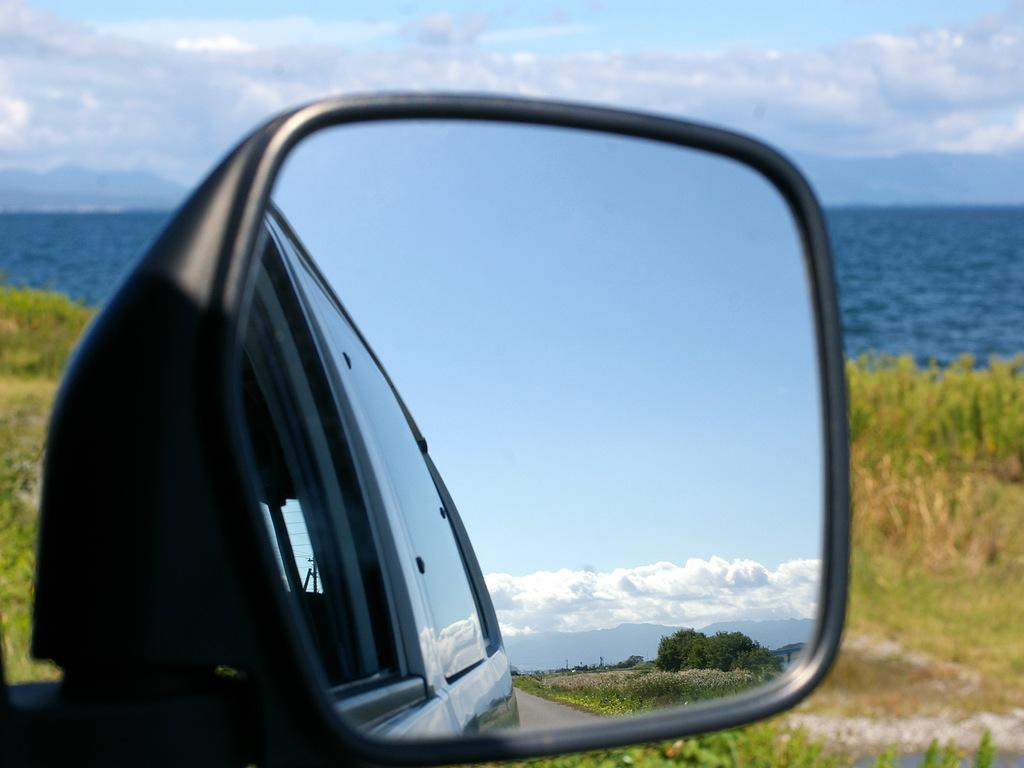What object in the image reflects its surroundings? The mirror in the image reflects its surroundings. What type of natural environment is visible in the image? There is grass and water visible in the image. What can be seen in the sky in the image? The sky is visible in the image, and clouds are present. What does the mirror reflect in the image? The mirror reflects trees and a vehicle in the image. How many times does the mirror fold in the image? The mirror does not fold in the image; it is a flat surface that reflects its surroundings. 